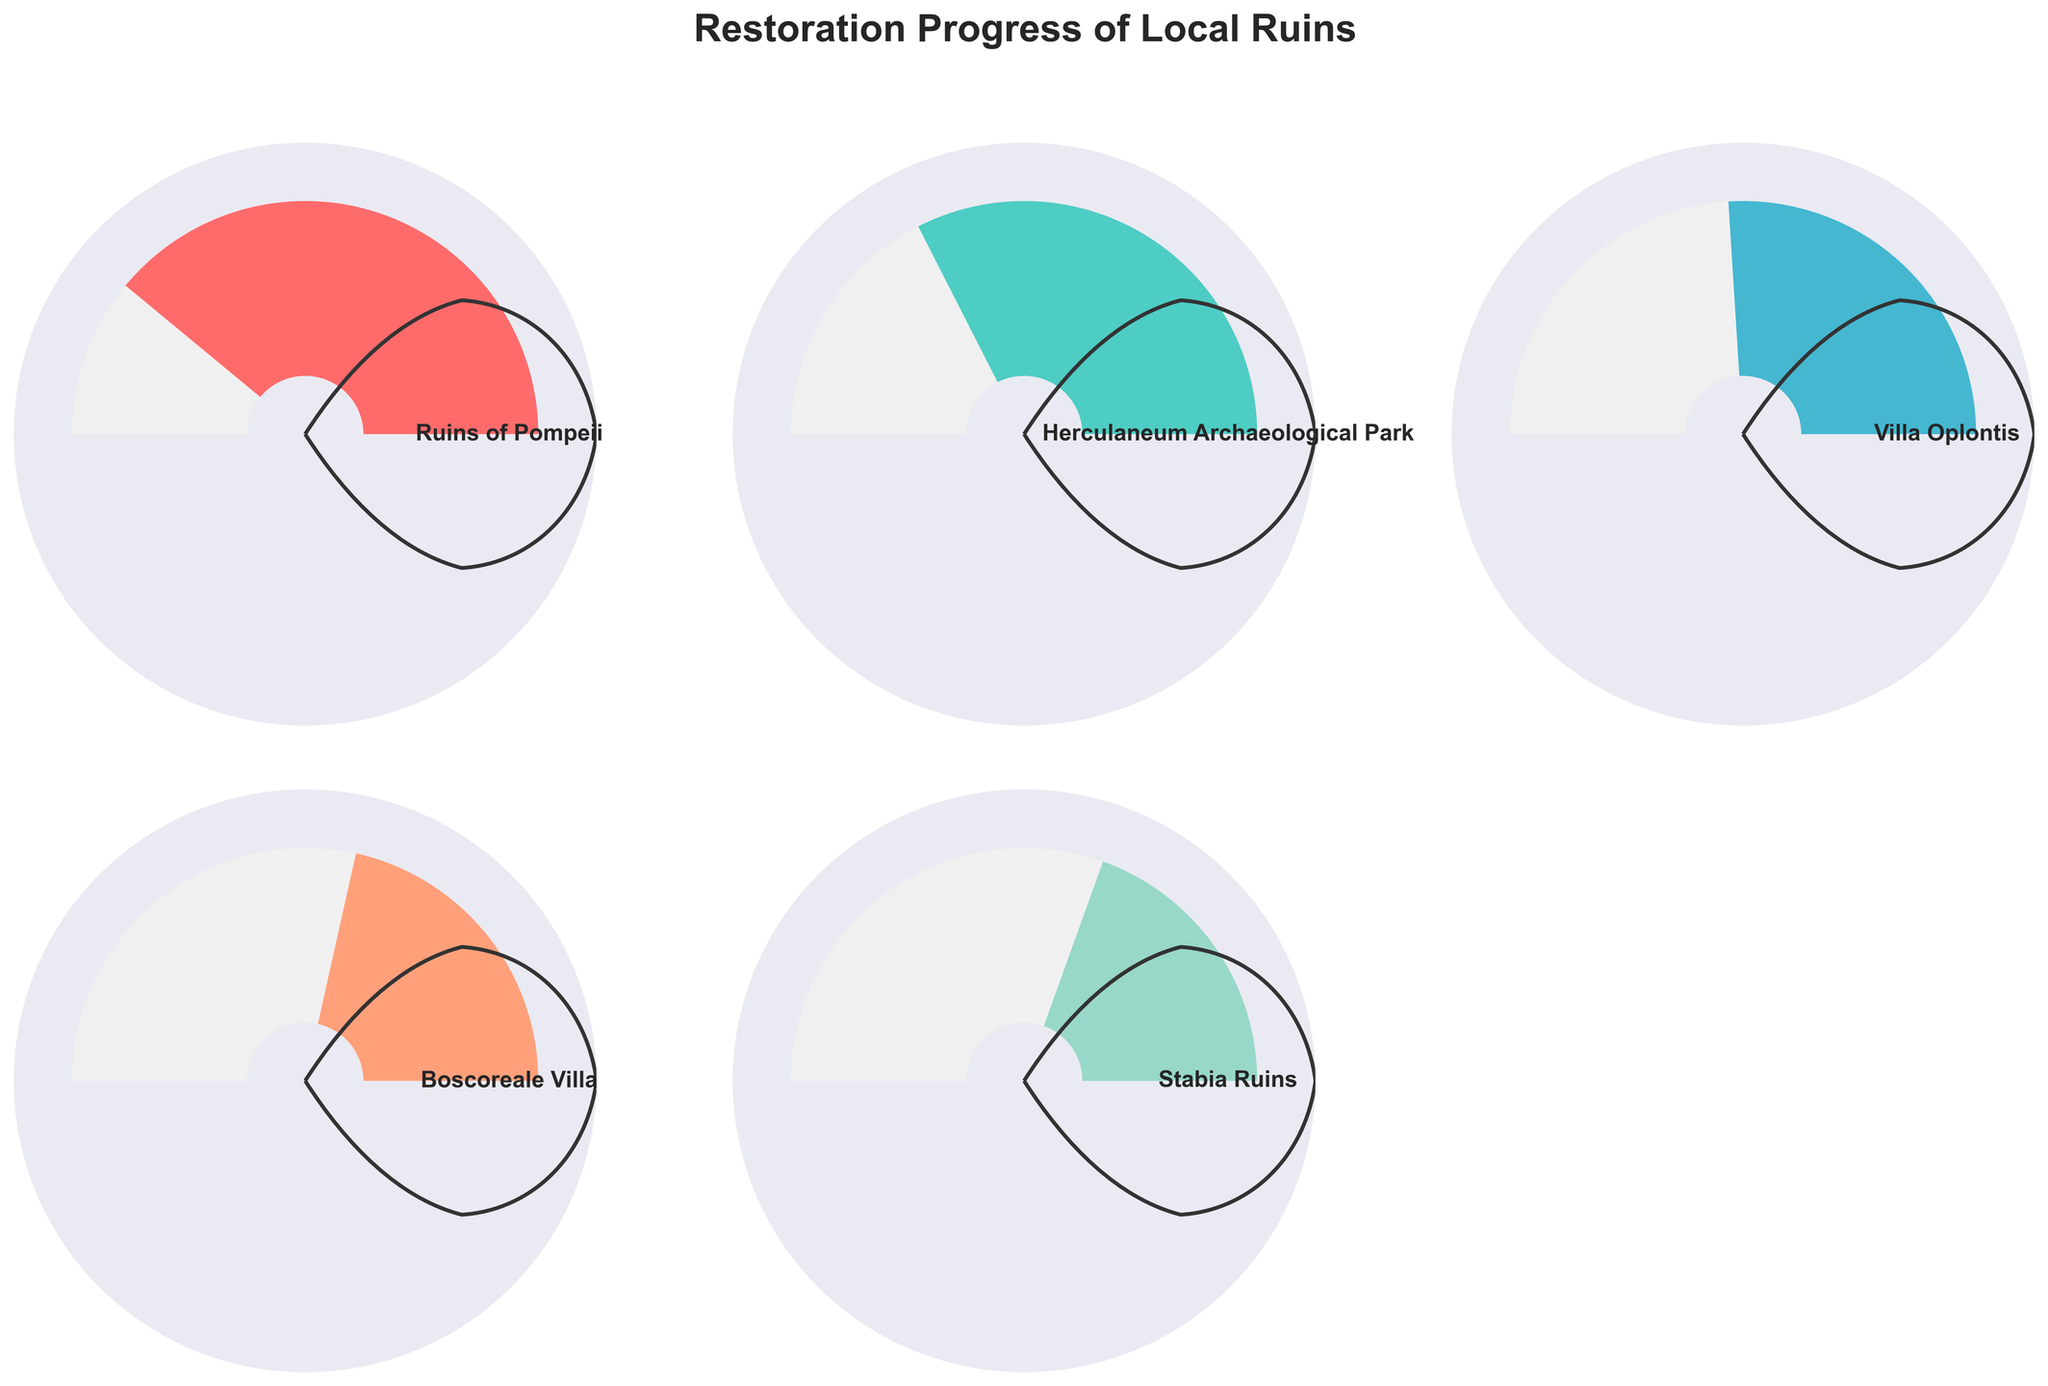What is the title of the figure? The title of the figure is usually displayed at the top of the plot. In this case, the title is displayed as "Restoration Progress of Local Ruins."
Answer: Restoration Progress of Local Ruins Which ruin has the highest percentage of restoration? By looking at the gauge charts, the ruin with the highest percentage is at the top of the list. The Ruins of Pompeii show the highest percentage with a value of 78%.
Answer: Ruins of Pompeii How many ruins have a restoration percentage above 50%? To determine this, visually inspect each gauge chart and count the number of ruins where the percentage is greater than 50%. The Ruins of Pompeii, Herculaneum Archaeological Park, and Villa Oplontis all have percentages above 50%, totaling three ruins.
Answer: 3 Which ruins have a restoration percentage that is less than 40%? By reviewing the gauge charts, the ruins that have percentages less than 40% are the Boscoreale Villa and the Stabia Ruins. The Boscoreale Villa has 43%, and the Stabia Ruins have 39%.
Answer: Boscoreale Villa, Stabia Ruins What's the average percentage of restoration for the listed ruins? To calculate the average, sum up all the percentages and divide by the number of ruins: (78 + 65 + 52 + 43 + 39) / 5 = 277 / 5 = 55.4
Answer: 55.4 Which ruin is the least restored, and what is its percentage? The least restored ruin will be the one with the smallest percentage displayed in the gauge chart. Stabia Ruins has the lowest percentage of 39%.
Answer: Stabia Ruins, 39% What is the difference in restoration percentage between the Ruins of Pompeii and the Stabia Ruins? Subtract the smaller percentage (Stabia Ruins) from the larger percentage (Ruins of Pompeii): 78% - 39% = 39%
Answer: 39% How many gauge charts are displayed in total? Count the individual gauge charts present in the figure. There are five gauge charts in total, one for each listed ruin.
Answer: 5 